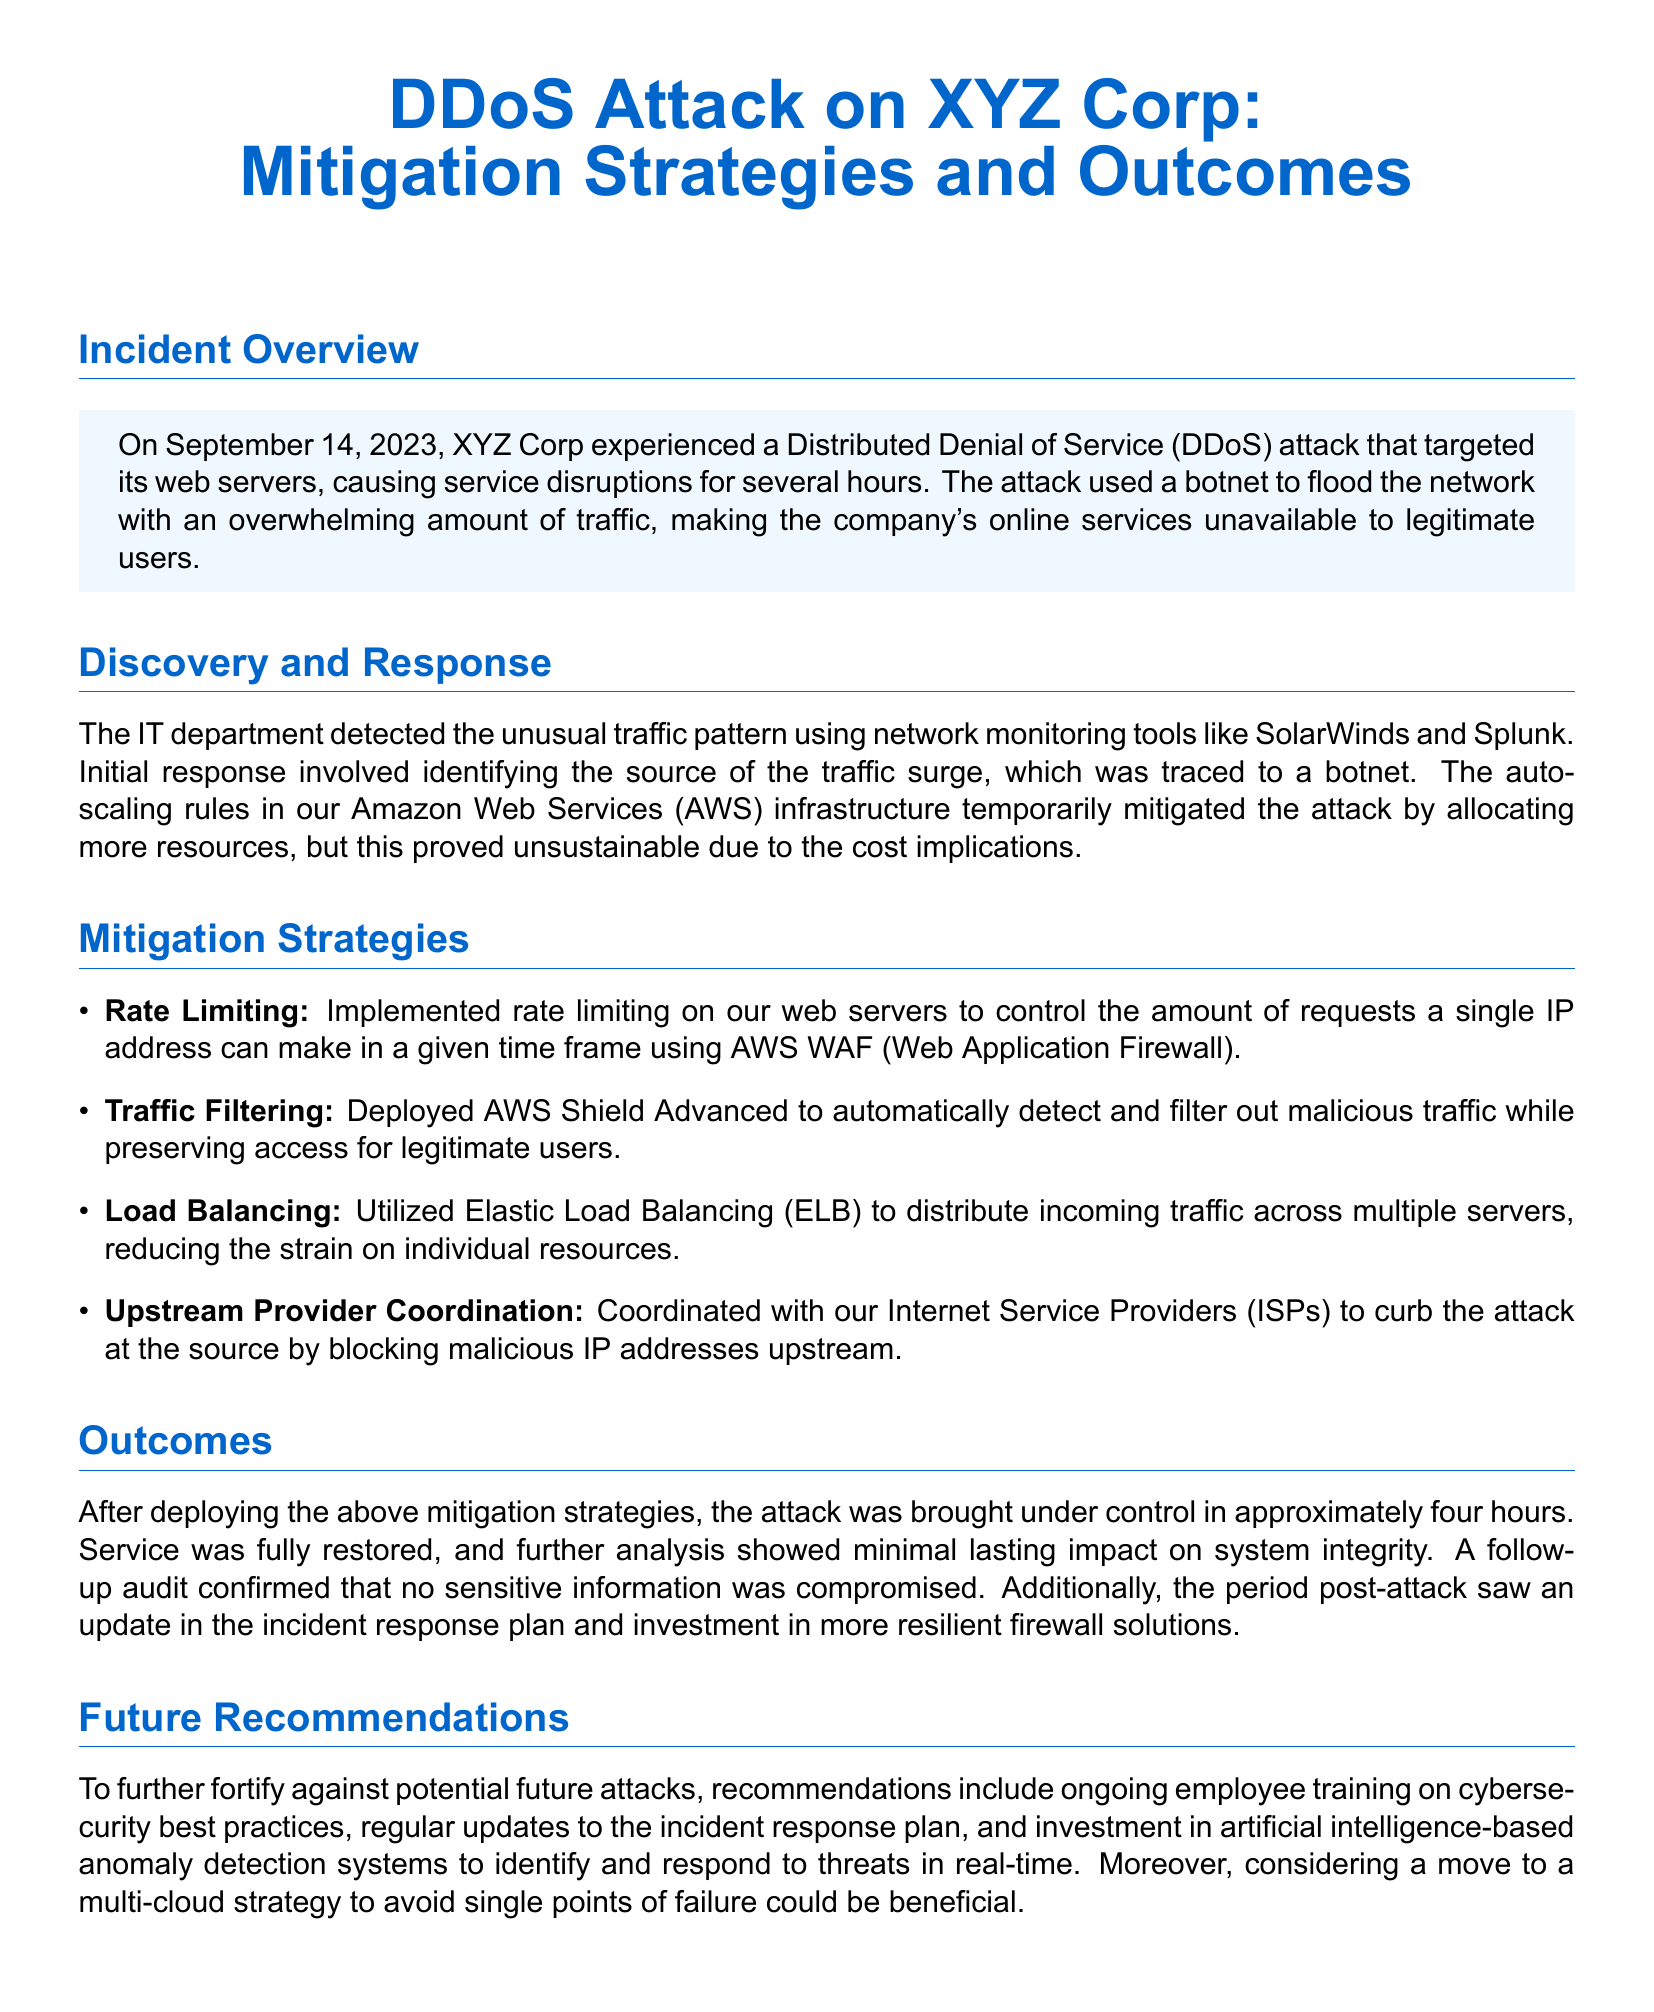What date did the DDoS attack occur? The date of the attack is specified in the document's introduction as September 14, 2023.
Answer: September 14, 2023 What was the primary method used in the attack? The document indicates that a botnet was used to flood the network with traffic during the attack.
Answer: Botnet How long did the attack last? The outcomes section mentions that the attack was brought under control in approximately four hours.
Answer: Four hours What tool was used for network monitoring? The discovery and response section lists SolarWinds and Splunk as the tools used for monitoring traffic patterns.
Answer: SolarWinds and Splunk Which mitigation strategy involved controlling requests from a single IP? Rate limiting is the strategy that was implemented to control the amount of requests a single IP address could make.
Answer: Rate Limiting What was the impact on system integrity post-attack? The outcomes section states that the analysis showed minimal lasting impact on system integrity after the attack.
Answer: Minimal lasting impact Which AWS service was used to filter out malicious traffic? AWS Shield Advanced was specifically mentioned as the service used to automatically filter out malicious traffic.
Answer: AWS Shield Advanced What future recommendation involves employee training? The document recommends ongoing employee training on cybersecurity best practices to fortify against future attacks.
Answer: Ongoing employee training How did the company respond to the attack's source? The company coordinated with Internet Service Providers (ISPs) to curb the attack at the source by blocking malicious IP addresses.
Answer: Coordinated with ISPs 